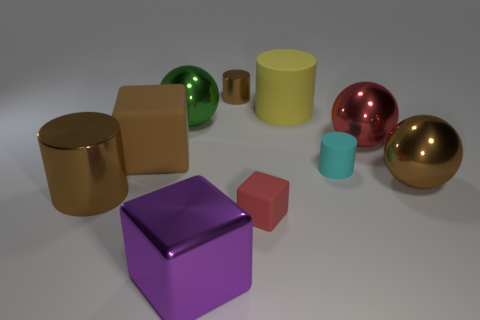Is there a purple object that has the same size as the red block?
Provide a short and direct response. No. There is another large rubber object that is the same shape as the red matte thing; what is its color?
Your answer should be very brief. Brown. Are there any small matte things in front of the tiny cyan cylinder right of the large purple thing?
Ensure brevity in your answer.  Yes. Does the large shiny thing that is in front of the small red cube have the same shape as the tiny red thing?
Provide a short and direct response. Yes. The brown rubber object is what shape?
Ensure brevity in your answer.  Cube. What number of large green objects have the same material as the small cube?
Your answer should be very brief. 0. There is a small matte cylinder; is it the same color as the shiny cylinder behind the red ball?
Provide a short and direct response. No. How many small cyan objects are there?
Ensure brevity in your answer.  1. Are there any large shiny balls of the same color as the large matte cube?
Your answer should be very brief. Yes. The small matte object that is in front of the brown thing that is in front of the brown metallic thing right of the big yellow matte cylinder is what color?
Provide a short and direct response. Red. 